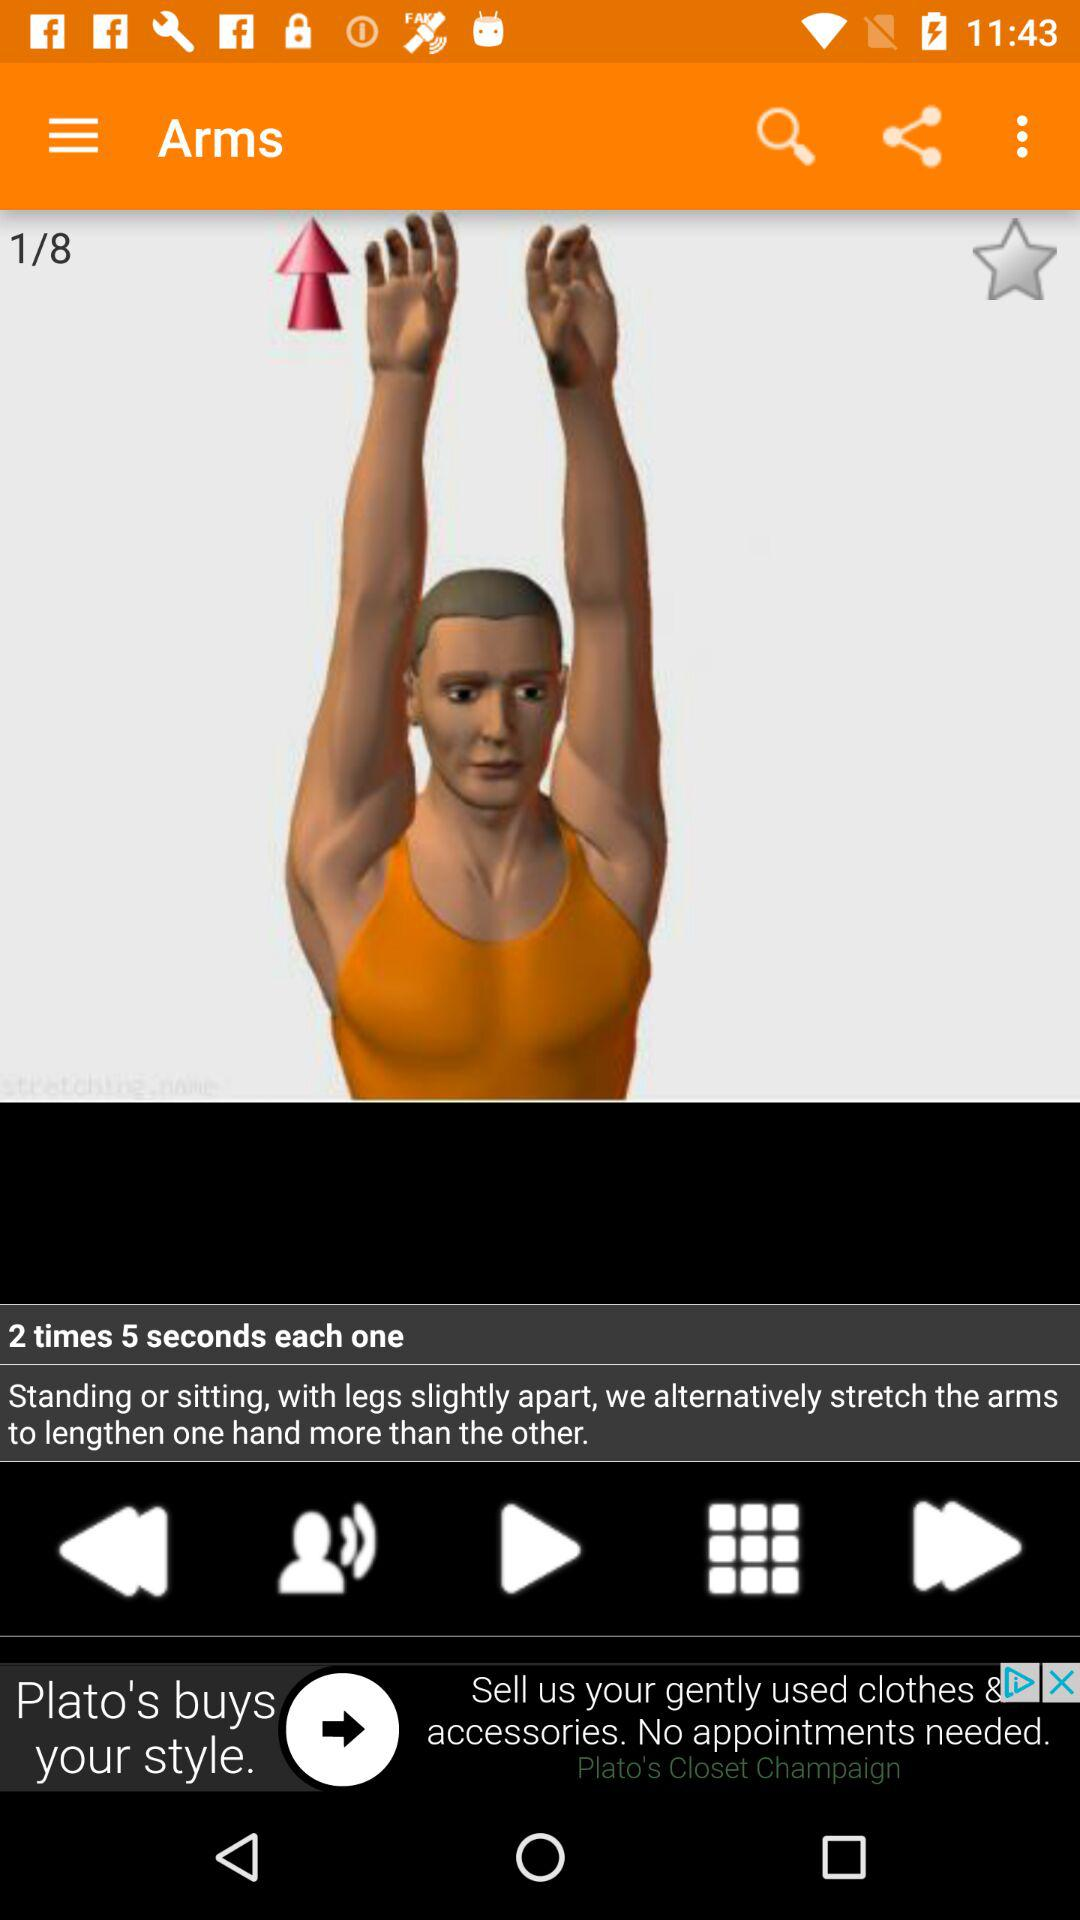How many exercises in total are there? There are 8 exercises in total. 